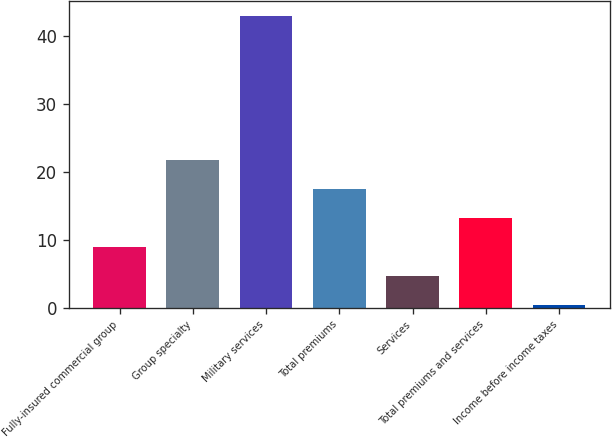<chart> <loc_0><loc_0><loc_500><loc_500><bar_chart><fcel>Fully-insured commercial group<fcel>Group specialty<fcel>Military services<fcel>Total premiums<fcel>Services<fcel>Total premiums and services<fcel>Income before income taxes<nl><fcel>8.9<fcel>21.65<fcel>42.9<fcel>17.4<fcel>4.65<fcel>13.15<fcel>0.4<nl></chart> 